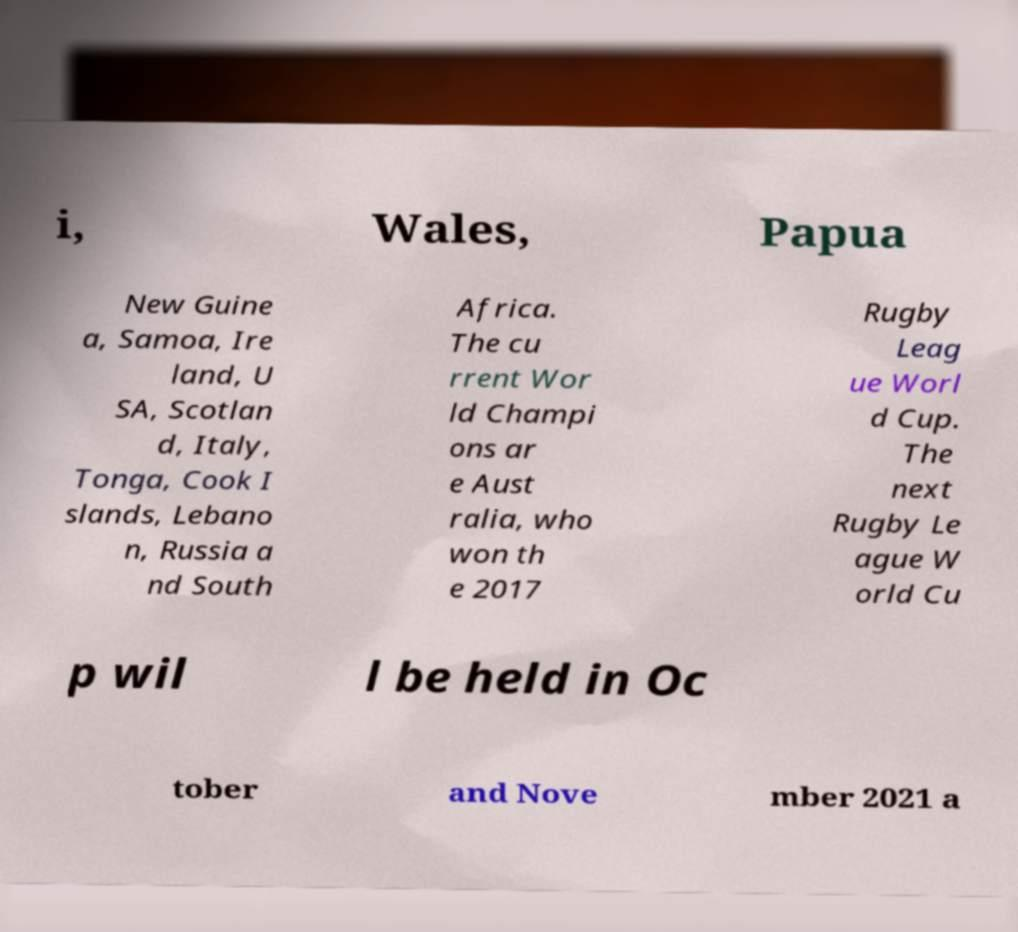What messages or text are displayed in this image? I need them in a readable, typed format. i, Wales, Papua New Guine a, Samoa, Ire land, U SA, Scotlan d, Italy, Tonga, Cook I slands, Lebano n, Russia a nd South Africa. The cu rrent Wor ld Champi ons ar e Aust ralia, who won th e 2017 Rugby Leag ue Worl d Cup. The next Rugby Le ague W orld Cu p wil l be held in Oc tober and Nove mber 2021 a 